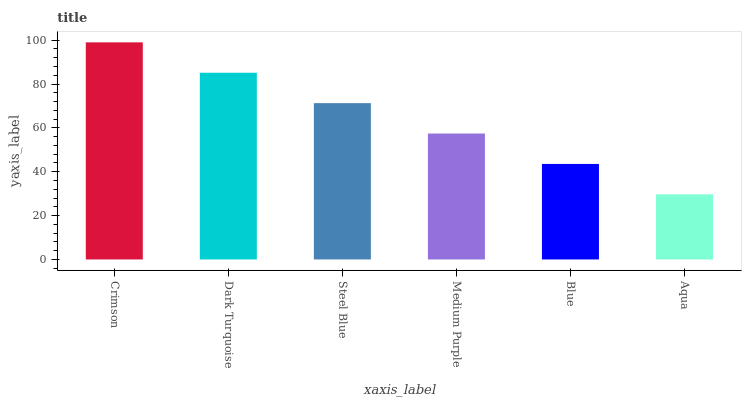Is Aqua the minimum?
Answer yes or no. Yes. Is Crimson the maximum?
Answer yes or no. Yes. Is Dark Turquoise the minimum?
Answer yes or no. No. Is Dark Turquoise the maximum?
Answer yes or no. No. Is Crimson greater than Dark Turquoise?
Answer yes or no. Yes. Is Dark Turquoise less than Crimson?
Answer yes or no. Yes. Is Dark Turquoise greater than Crimson?
Answer yes or no. No. Is Crimson less than Dark Turquoise?
Answer yes or no. No. Is Steel Blue the high median?
Answer yes or no. Yes. Is Medium Purple the low median?
Answer yes or no. Yes. Is Dark Turquoise the high median?
Answer yes or no. No. Is Blue the low median?
Answer yes or no. No. 